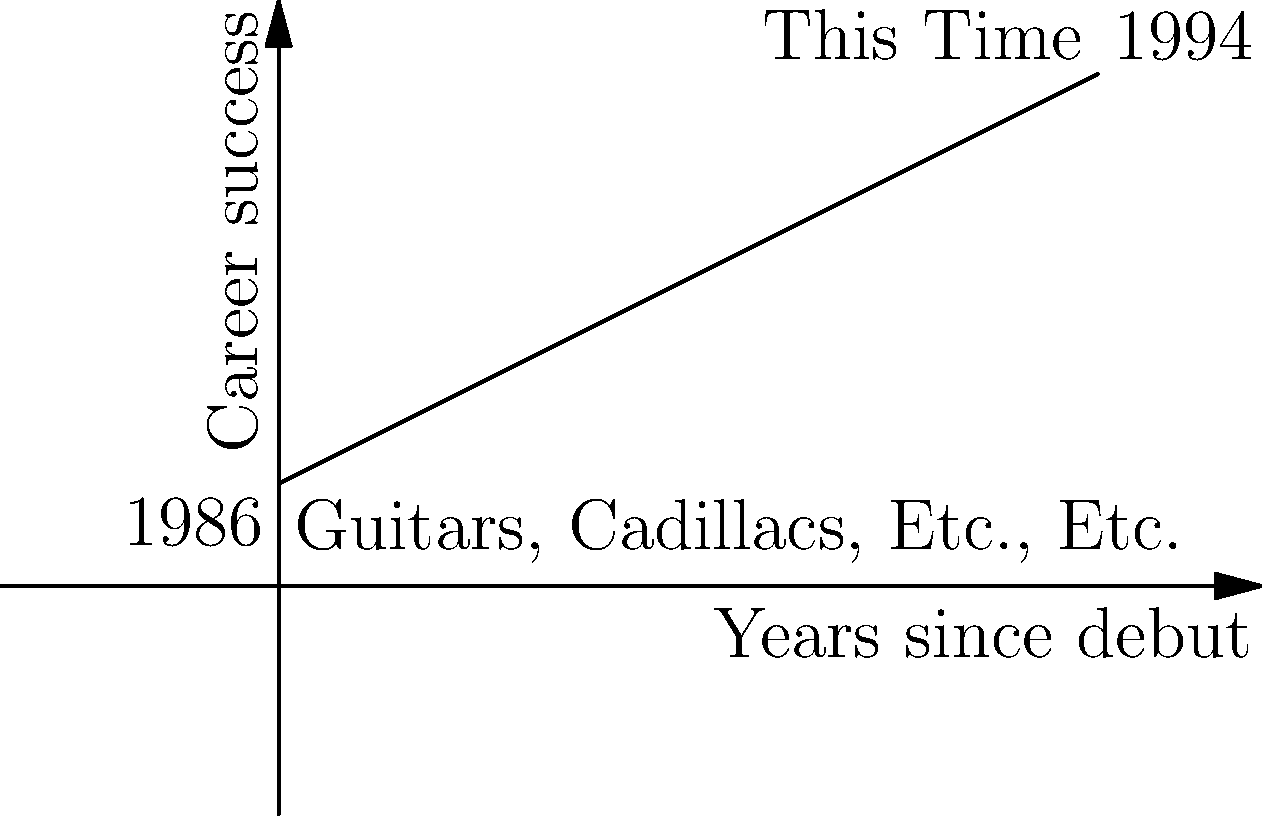The graph represents Dwight Yoakam's career trajectory from his debut album "Guitars, Cadillacs, Etc., Etc." in 1986 to his critically acclaimed album "This Time" in 1994. If we consider the x-axis as years since debut and the y-axis as a measure of career success, what is the slope of Dwight Yoakam's career trajectory during this period? Round your answer to two decimal places. To find the slope of Dwight Yoakam's career trajectory, we need to use the slope formula:

$$ m = \frac{y_2 - y_1}{x_2 - x_1} $$

Where:
$(x_1, y_1)$ represents the point for the debut album in 1986
$(x_2, y_2)$ represents the point for "This Time" in 1994

From the graph:
$x_1 = 0$ (1986 is the starting point)
$y_1 = 1$ (initial success level)
$x_2 = 8$ (8 years between 1986 and 1994)
$y_2 = 5$ (success level in 1994)

Plugging these values into the slope formula:

$$ m = \frac{5 - 1}{8 - 0} = \frac{4}{8} = 0.5 $$

The slope of Dwight Yoakam's career trajectory from 1986 to 1994 is 0.5, which indicates a steady increase in his career success over this period.
Answer: 0.5 